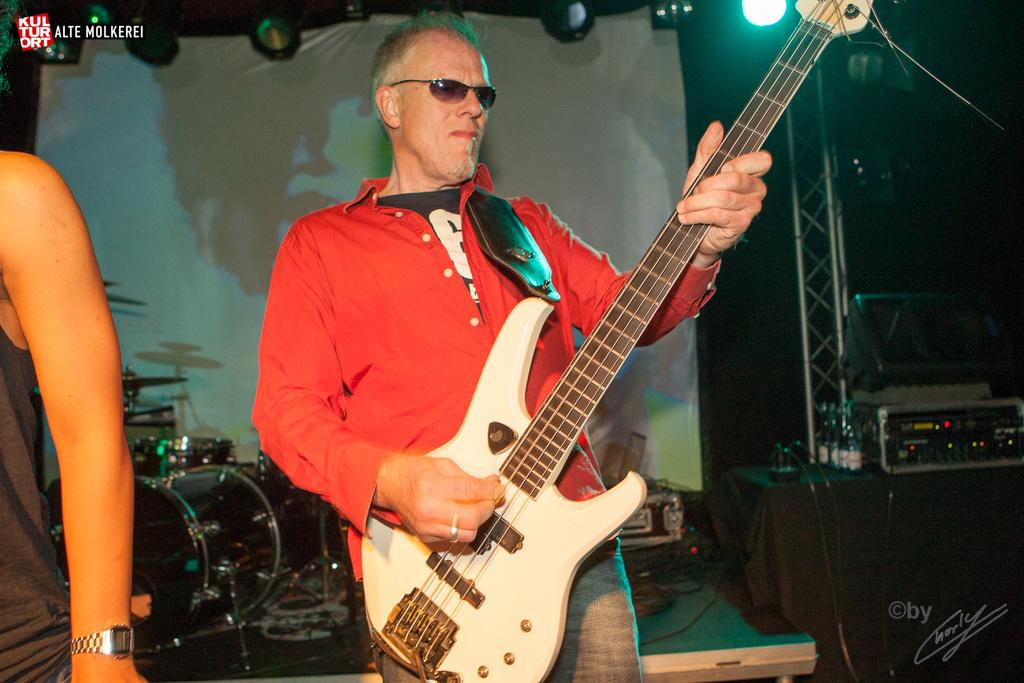What is the man in the image doing? The man is playing a guitar in the image. What can be seen on the man's face? The man is wearing spectacles in the image. What else is present in the image besides the man? There are musical instruments in the background and a white cloth visible in the image. Can you describe the lighting in the image? There is a light in the image. What type of treatment is the man receiving for his celery allergy in the image? There is no mention of a celery allergy or any treatment in the image; the man is simply playing a guitar. Where is the cave located in the image? There is no cave present in the image. 